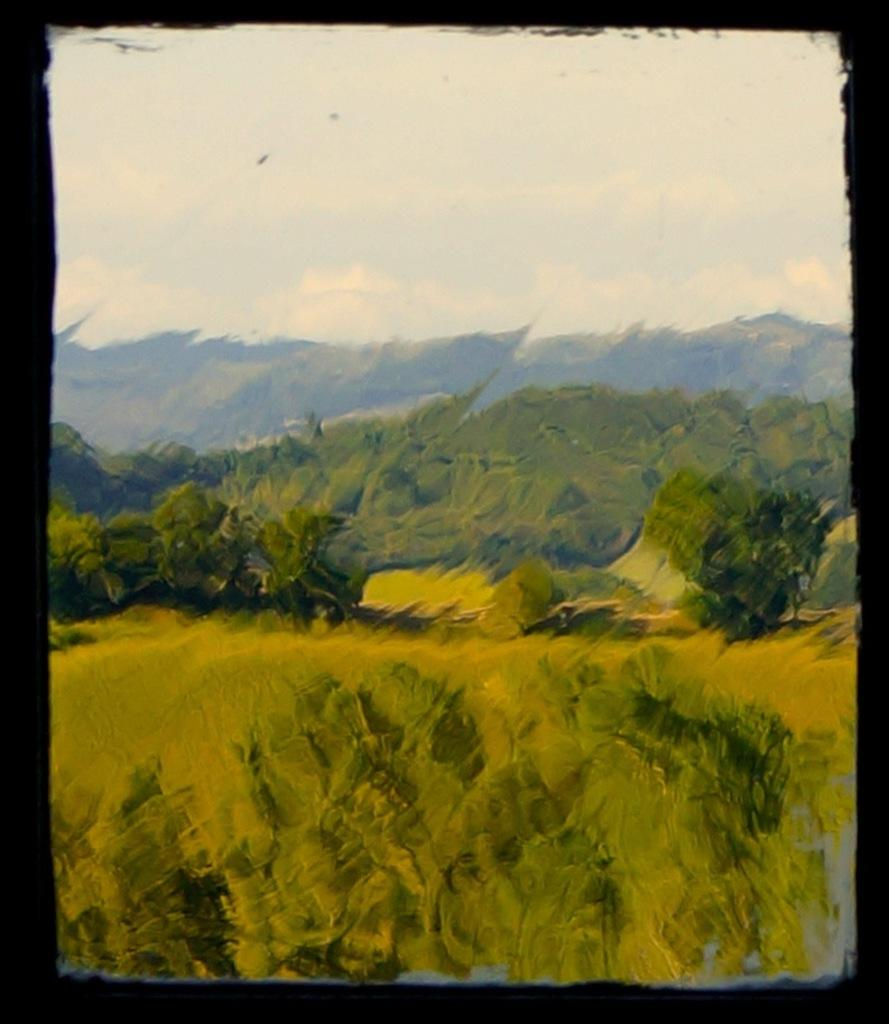What is the main subject of the painting? The painting depicts mountains. What type of vegetation can be seen in the painting? Trees, plants, and grass are visible in the painting. What is visible in the sky of the painting? Clouds are present in the sky of the painting. Where is the daughter being held in the painting? There is no daughter present in the painting; it depicts mountains, trees, plants, grass, and clouds. Is there a jail visible in the painting? No, there is no jail present in the painting. 